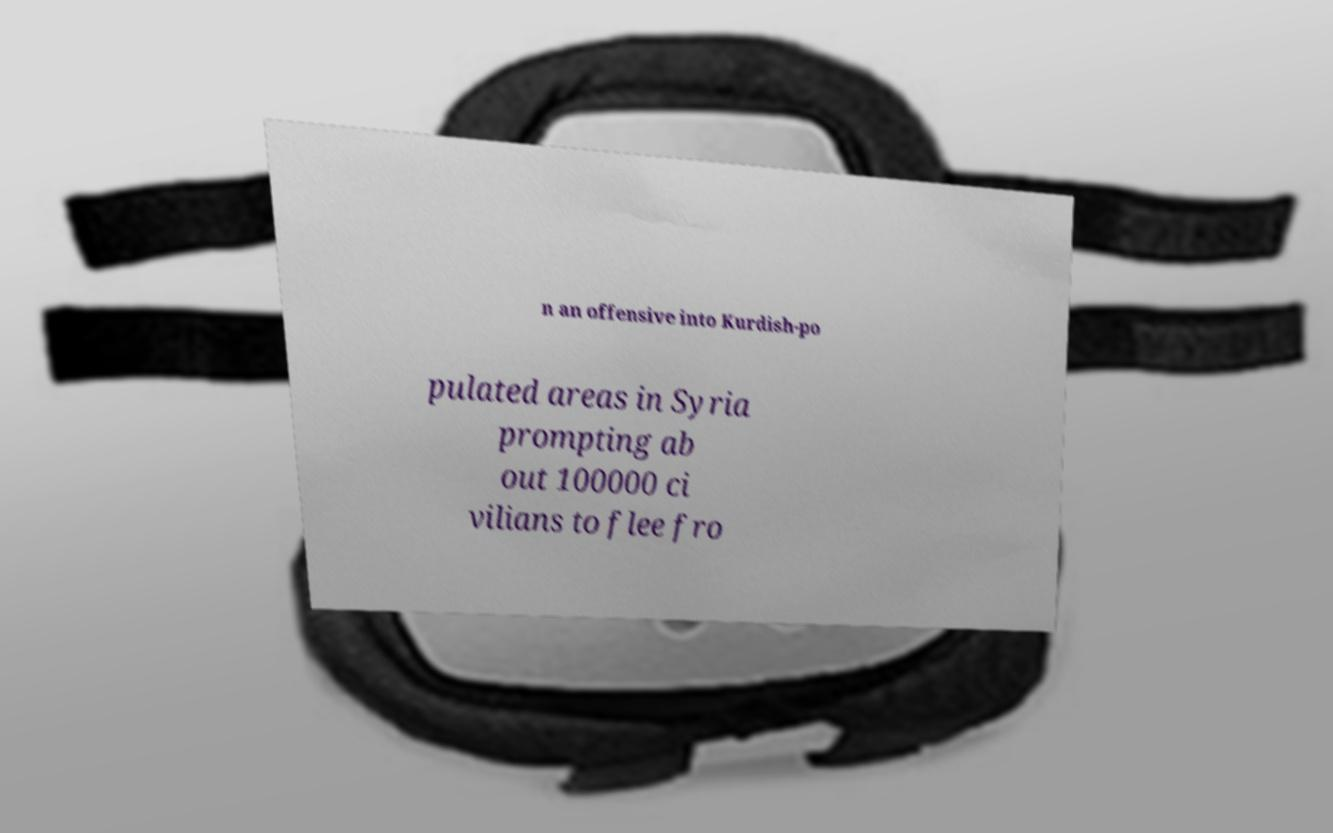Please read and relay the text visible in this image. What does it say? n an offensive into Kurdish-po pulated areas in Syria prompting ab out 100000 ci vilians to flee fro 